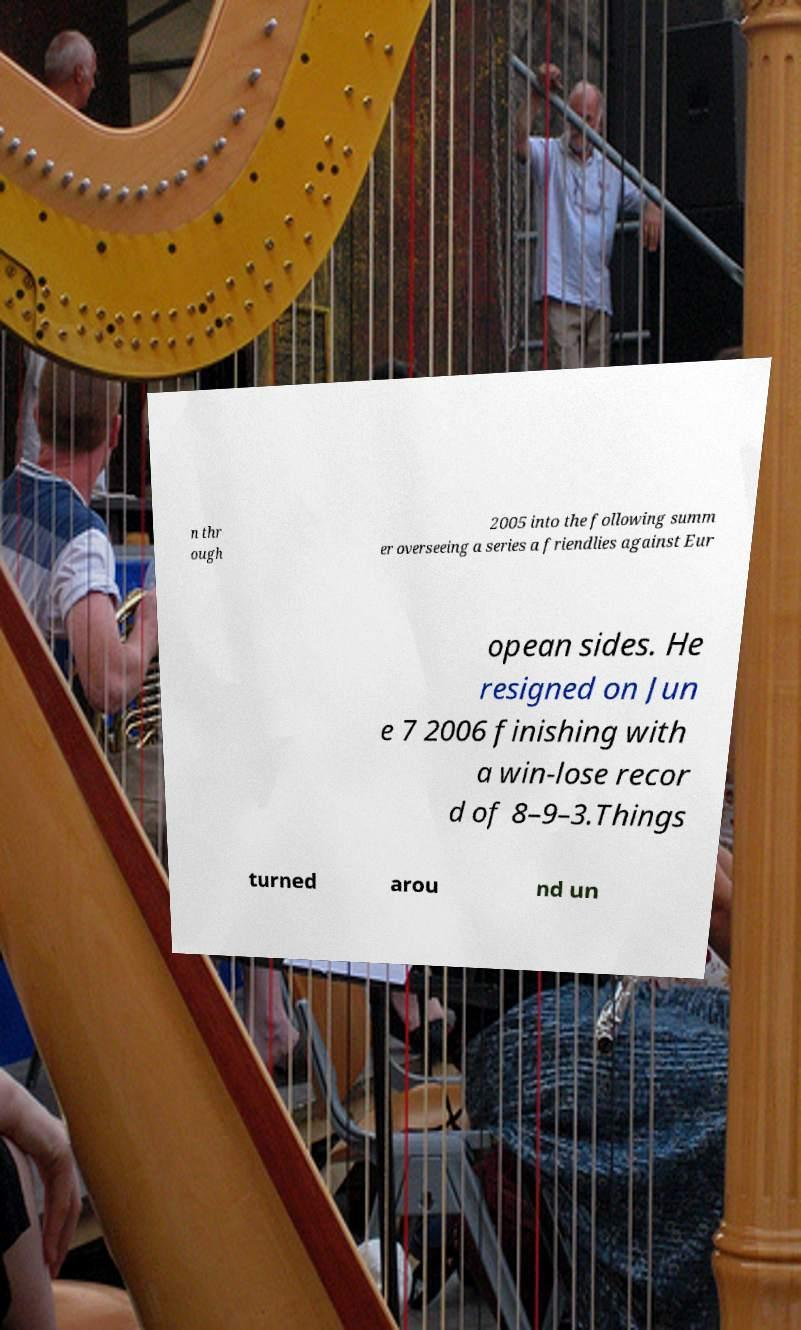There's text embedded in this image that I need extracted. Can you transcribe it verbatim? n thr ough 2005 into the following summ er overseeing a series a friendlies against Eur opean sides. He resigned on Jun e 7 2006 finishing with a win-lose recor d of 8–9–3.Things turned arou nd un 